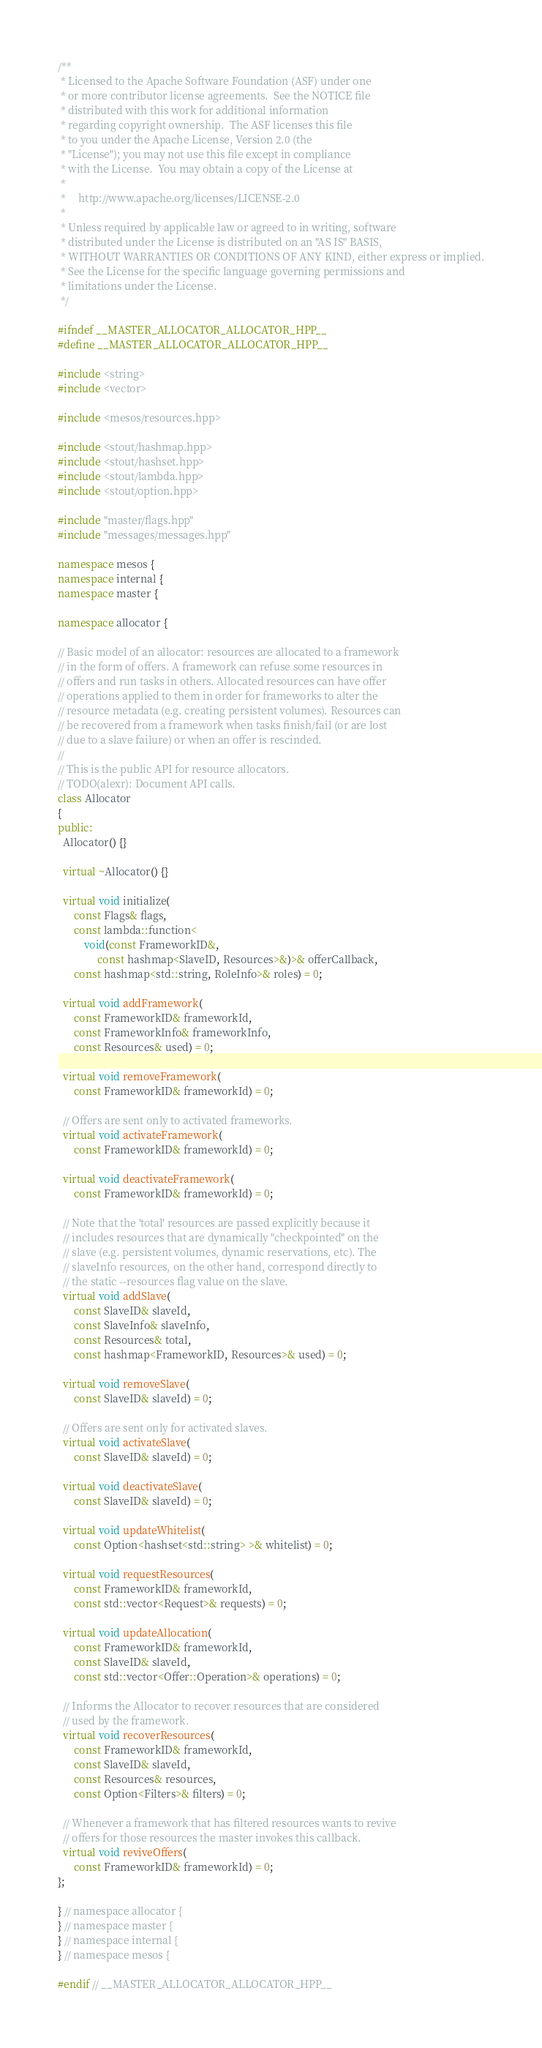Convert code to text. <code><loc_0><loc_0><loc_500><loc_500><_C++_>/**
 * Licensed to the Apache Software Foundation (ASF) under one
 * or more contributor license agreements.  See the NOTICE file
 * distributed with this work for additional information
 * regarding copyright ownership.  The ASF licenses this file
 * to you under the Apache License, Version 2.0 (the
 * "License"); you may not use this file except in compliance
 * with the License.  You may obtain a copy of the License at
 *
 *     http://www.apache.org/licenses/LICENSE-2.0
 *
 * Unless required by applicable law or agreed to in writing, software
 * distributed under the License is distributed on an "AS IS" BASIS,
 * WITHOUT WARRANTIES OR CONDITIONS OF ANY KIND, either express or implied.
 * See the License for the specific language governing permissions and
 * limitations under the License.
 */

#ifndef __MASTER_ALLOCATOR_ALLOCATOR_HPP__
#define __MASTER_ALLOCATOR_ALLOCATOR_HPP__

#include <string>
#include <vector>

#include <mesos/resources.hpp>

#include <stout/hashmap.hpp>
#include <stout/hashset.hpp>
#include <stout/lambda.hpp>
#include <stout/option.hpp>

#include "master/flags.hpp"
#include "messages/messages.hpp"

namespace mesos {
namespace internal {
namespace master {

namespace allocator {

// Basic model of an allocator: resources are allocated to a framework
// in the form of offers. A framework can refuse some resources in
// offers and run tasks in others. Allocated resources can have offer
// operations applied to them in order for frameworks to alter the
// resource metadata (e.g. creating persistent volumes). Resources can
// be recovered from a framework when tasks finish/fail (or are lost
// due to a slave failure) or when an offer is rescinded.
//
// This is the public API for resource allocators.
// TODO(alexr): Document API calls.
class Allocator
{
public:
  Allocator() {}

  virtual ~Allocator() {}

  virtual void initialize(
      const Flags& flags,
      const lambda::function<
          void(const FrameworkID&,
               const hashmap<SlaveID, Resources>&)>& offerCallback,
      const hashmap<std::string, RoleInfo>& roles) = 0;

  virtual void addFramework(
      const FrameworkID& frameworkId,
      const FrameworkInfo& frameworkInfo,
      const Resources& used) = 0;

  virtual void removeFramework(
      const FrameworkID& frameworkId) = 0;

  // Offers are sent only to activated frameworks.
  virtual void activateFramework(
      const FrameworkID& frameworkId) = 0;

  virtual void deactivateFramework(
      const FrameworkID& frameworkId) = 0;

  // Note that the 'total' resources are passed explicitly because it
  // includes resources that are dynamically "checkpointed" on the
  // slave (e.g. persistent volumes, dynamic reservations, etc). The
  // slaveInfo resources, on the other hand, correspond directly to
  // the static --resources flag value on the slave.
  virtual void addSlave(
      const SlaveID& slaveId,
      const SlaveInfo& slaveInfo,
      const Resources& total,
      const hashmap<FrameworkID, Resources>& used) = 0;

  virtual void removeSlave(
      const SlaveID& slaveId) = 0;

  // Offers are sent only for activated slaves.
  virtual void activateSlave(
      const SlaveID& slaveId) = 0;

  virtual void deactivateSlave(
      const SlaveID& slaveId) = 0;

  virtual void updateWhitelist(
      const Option<hashset<std::string> >& whitelist) = 0;

  virtual void requestResources(
      const FrameworkID& frameworkId,
      const std::vector<Request>& requests) = 0;

  virtual void updateAllocation(
      const FrameworkID& frameworkId,
      const SlaveID& slaveId,
      const std::vector<Offer::Operation>& operations) = 0;

  // Informs the Allocator to recover resources that are considered
  // used by the framework.
  virtual void recoverResources(
      const FrameworkID& frameworkId,
      const SlaveID& slaveId,
      const Resources& resources,
      const Option<Filters>& filters) = 0;

  // Whenever a framework that has filtered resources wants to revive
  // offers for those resources the master invokes this callback.
  virtual void reviveOffers(
      const FrameworkID& frameworkId) = 0;
};

} // namespace allocator {
} // namespace master {
} // namespace internal {
} // namespace mesos {

#endif // __MASTER_ALLOCATOR_ALLOCATOR_HPP__
</code> 